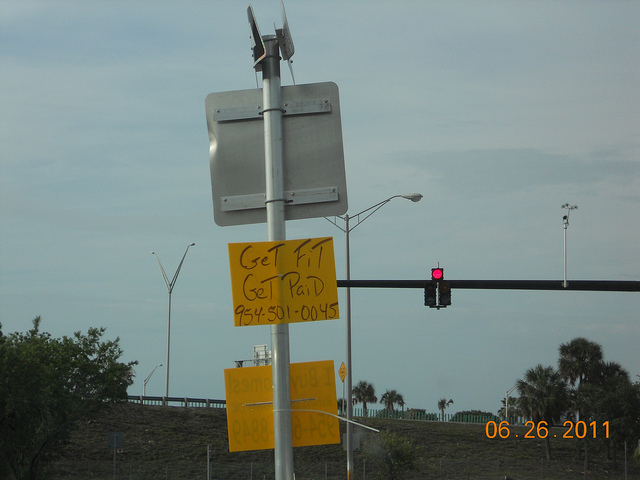Identify and read out the text in this image. 06 26 2011 GeT FiT 954-501-0045 PaiD Get 